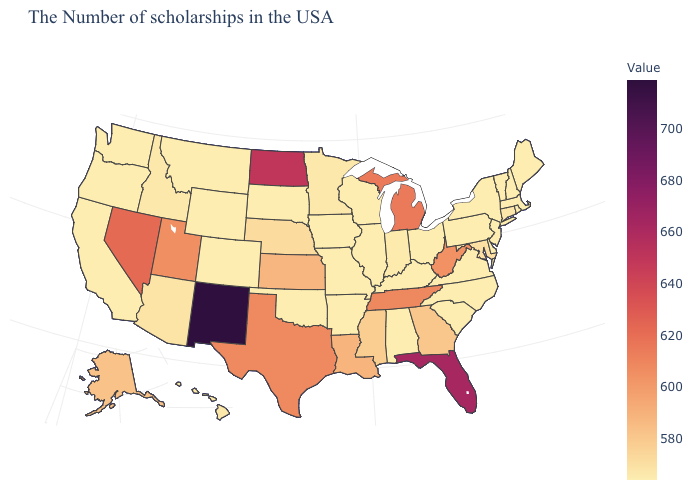Does Mississippi have the lowest value in the USA?
Quick response, please. No. Among the states that border North Carolina , which have the lowest value?
Keep it brief. Virginia, South Carolina. 